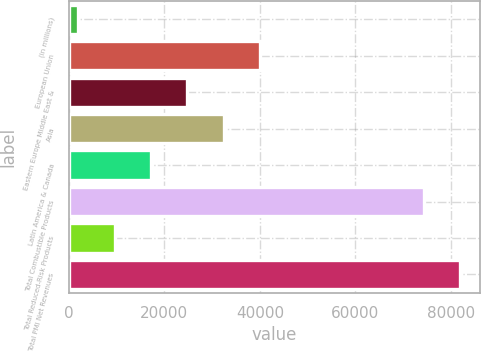Convert chart to OTSL. <chart><loc_0><loc_0><loc_500><loc_500><bar_chart><fcel>(in millions)<fcel>European Union<fcel>Eastern Europe Middle East &<fcel>Asia<fcel>Latin America & Canada<fcel>Total Combustible Products<fcel>Total Reduced-Risk Products<fcel>Total PMI Net Revenues<nl><fcel>2017<fcel>40057.5<fcel>24841.3<fcel>32449.4<fcel>17233.2<fcel>74305<fcel>9625.1<fcel>81913.1<nl></chart> 